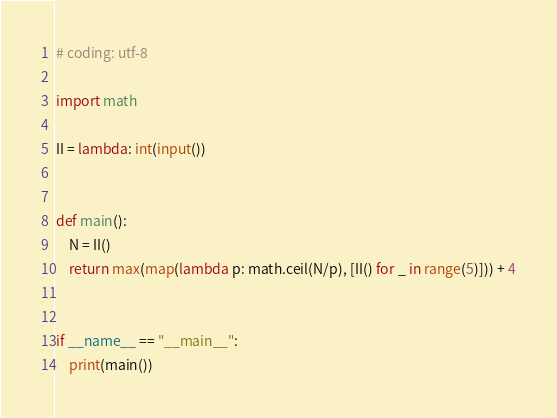<code> <loc_0><loc_0><loc_500><loc_500><_Python_># coding: utf-8

import math

II = lambda: int(input())


def main():
    N = II()
    return max(map(lambda p: math.ceil(N/p), [II() for _ in range(5)])) + 4


if __name__ == "__main__":
    print(main())
</code> 